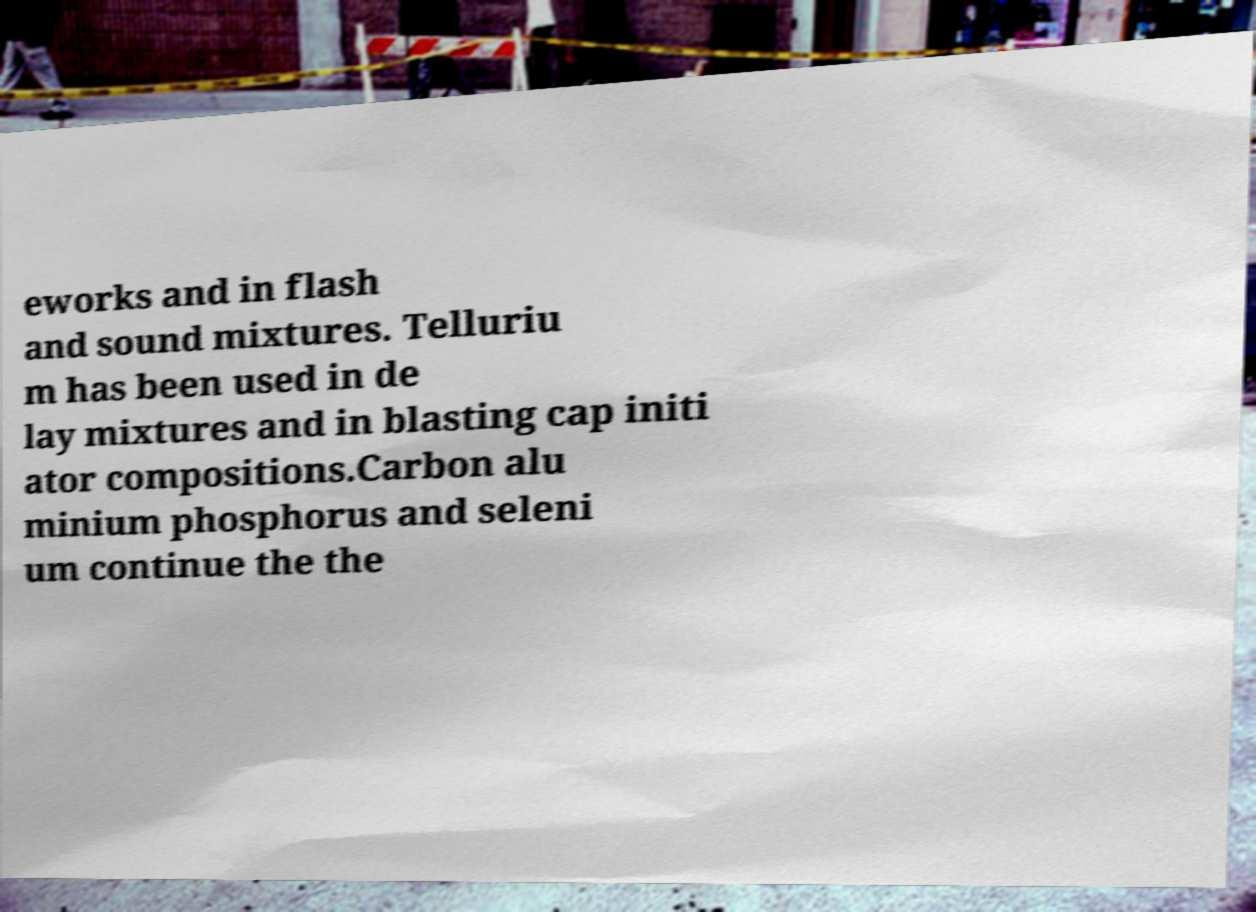Please identify and transcribe the text found in this image. eworks and in flash and sound mixtures. Telluriu m has been used in de lay mixtures and in blasting cap initi ator compositions.Carbon alu minium phosphorus and seleni um continue the the 